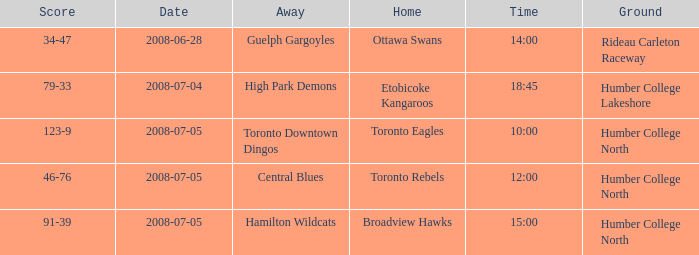What is the Away with a Time that is 14:00? Guelph Gargoyles. 